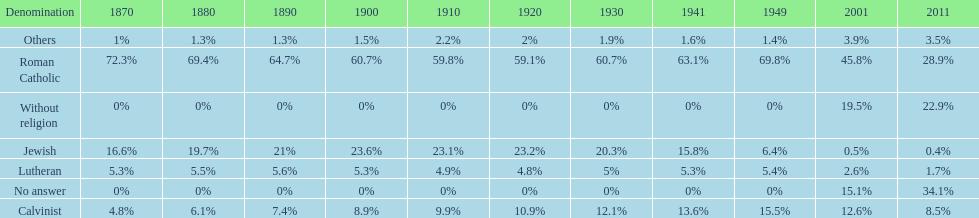Which denomination percentage increased the most after 1949? Without religion. 